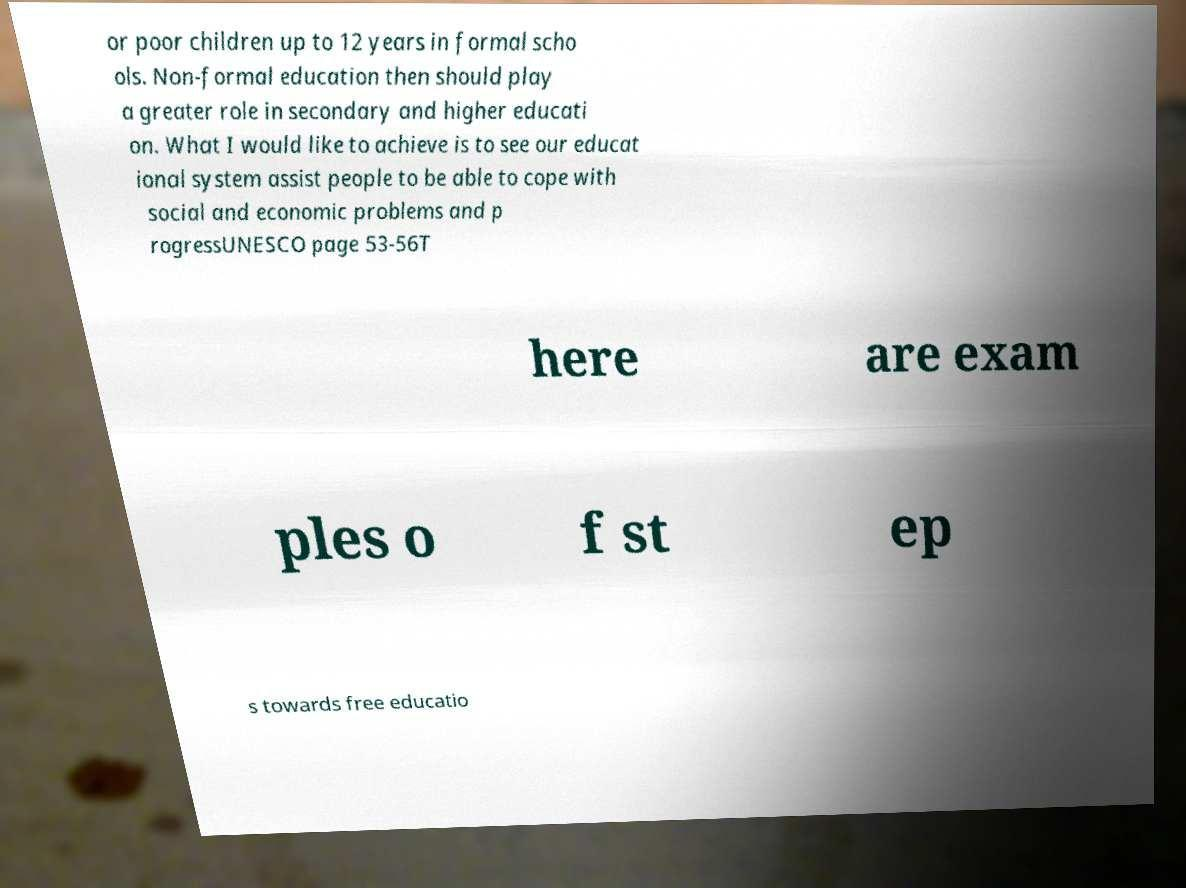For documentation purposes, I need the text within this image transcribed. Could you provide that? or poor children up to 12 years in formal scho ols. Non-formal education then should play a greater role in secondary and higher educati on. What I would like to achieve is to see our educat ional system assist people to be able to cope with social and economic problems and p rogressUNESCO page 53-56T here are exam ples o f st ep s towards free educatio 